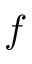<formula> <loc_0><loc_0><loc_500><loc_500>\boldsymbol f</formula> 